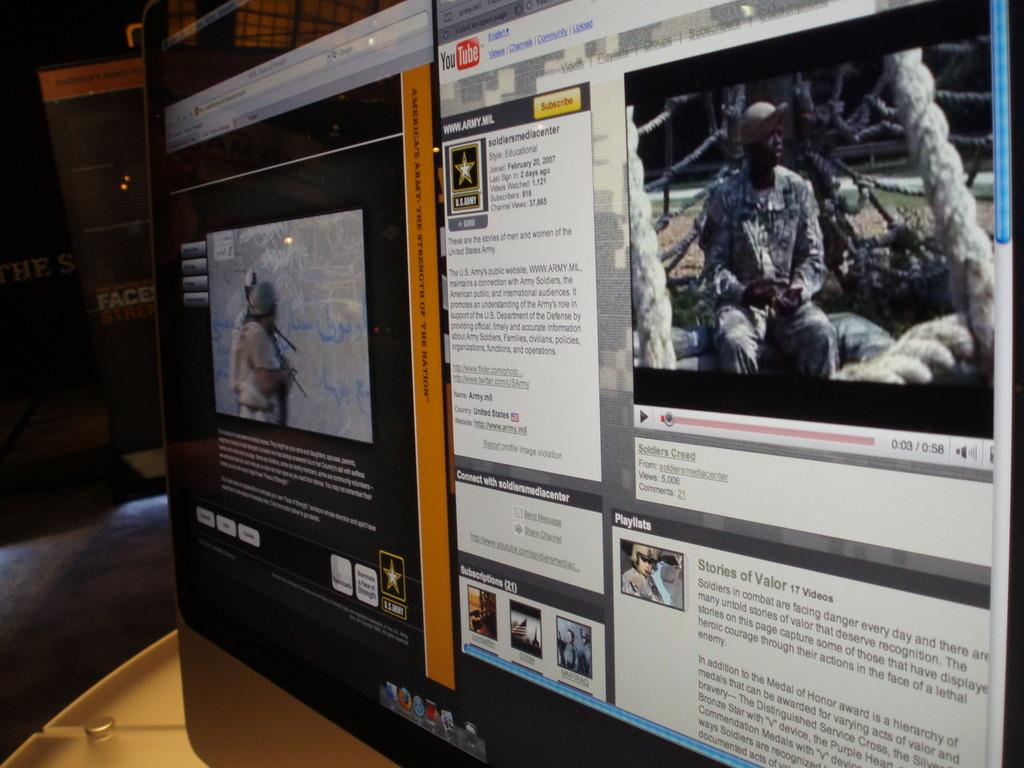<image>
Write a terse but informative summary of the picture. Screen that shows the us army and the military men in uniform 